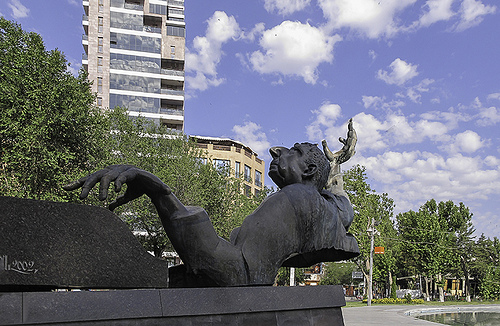<image>
Can you confirm if the right building is in front of the left building? Yes. The right building is positioned in front of the left building, appearing closer to the camera viewpoint. 